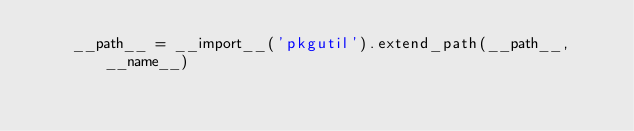<code> <loc_0><loc_0><loc_500><loc_500><_Python_>    __path__ = __import__('pkgutil').extend_path(__path__, __name__)
</code> 